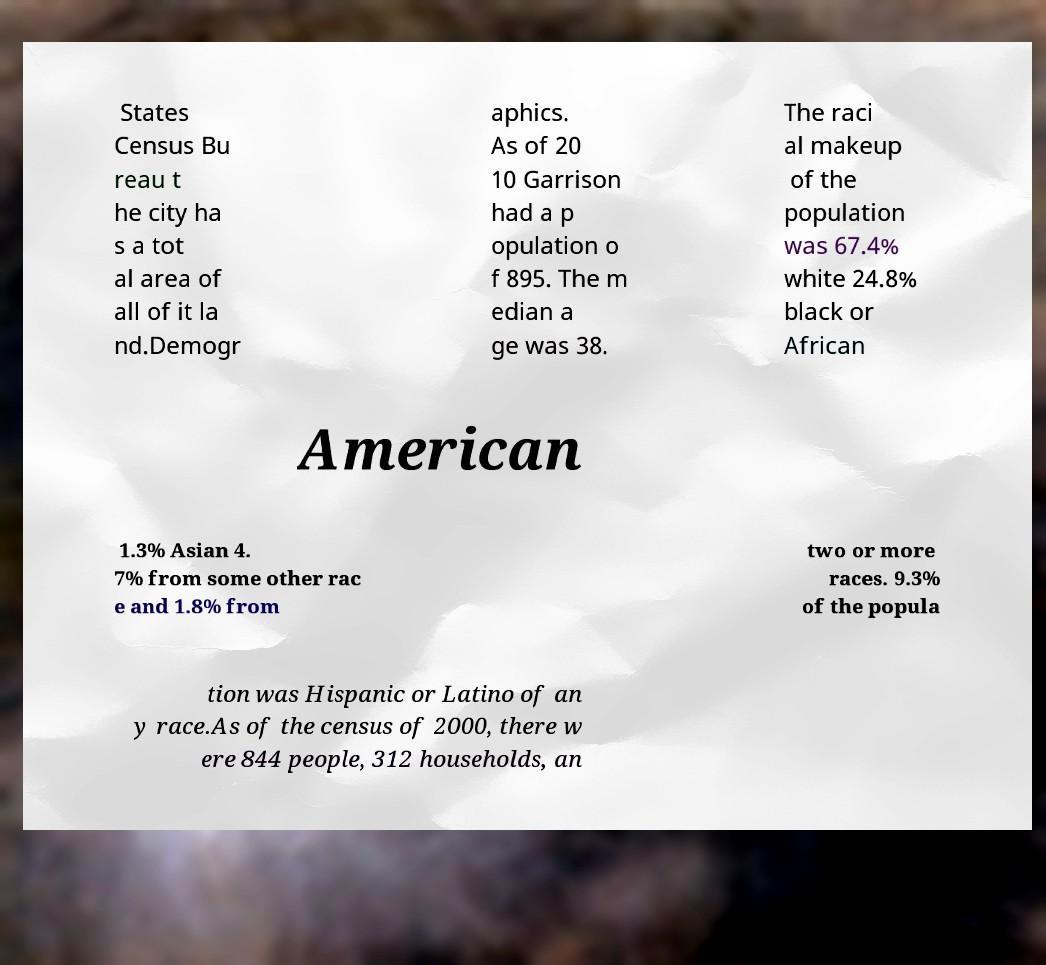What messages or text are displayed in this image? I need them in a readable, typed format. States Census Bu reau t he city ha s a tot al area of all of it la nd.Demogr aphics. As of 20 10 Garrison had a p opulation o f 895. The m edian a ge was 38. The raci al makeup of the population was 67.4% white 24.8% black or African American 1.3% Asian 4. 7% from some other rac e and 1.8% from two or more races. 9.3% of the popula tion was Hispanic or Latino of an y race.As of the census of 2000, there w ere 844 people, 312 households, an 